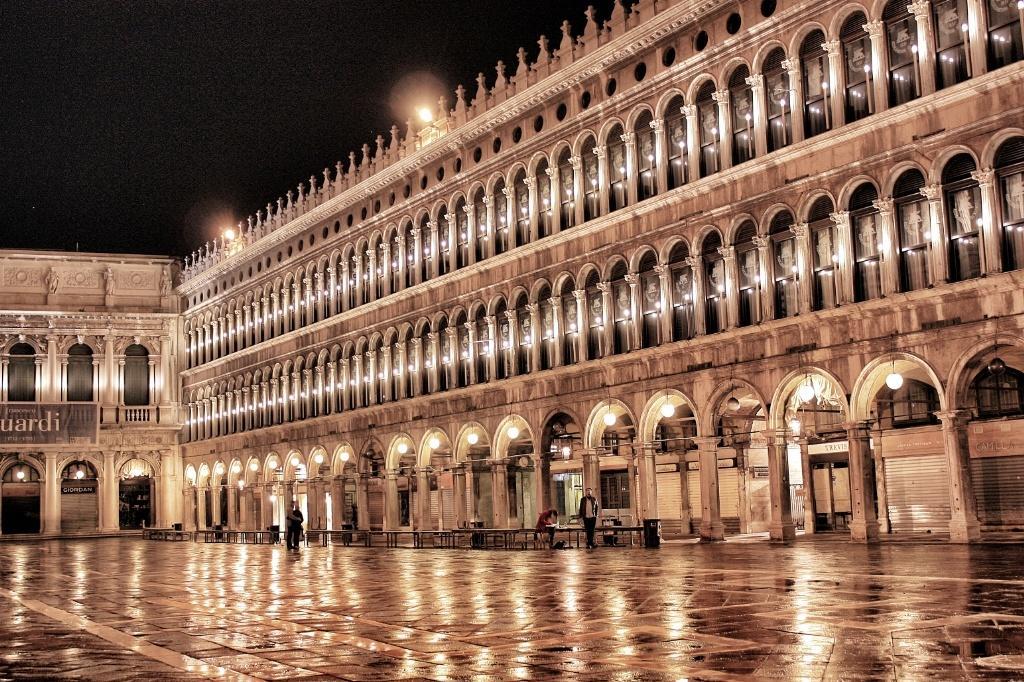In one or two sentences, can you explain what this image depicts? In this I can see buildings and I can see few tables on the floor and I can see couple of them standing and couple of banners with some text and I can see few lights. 